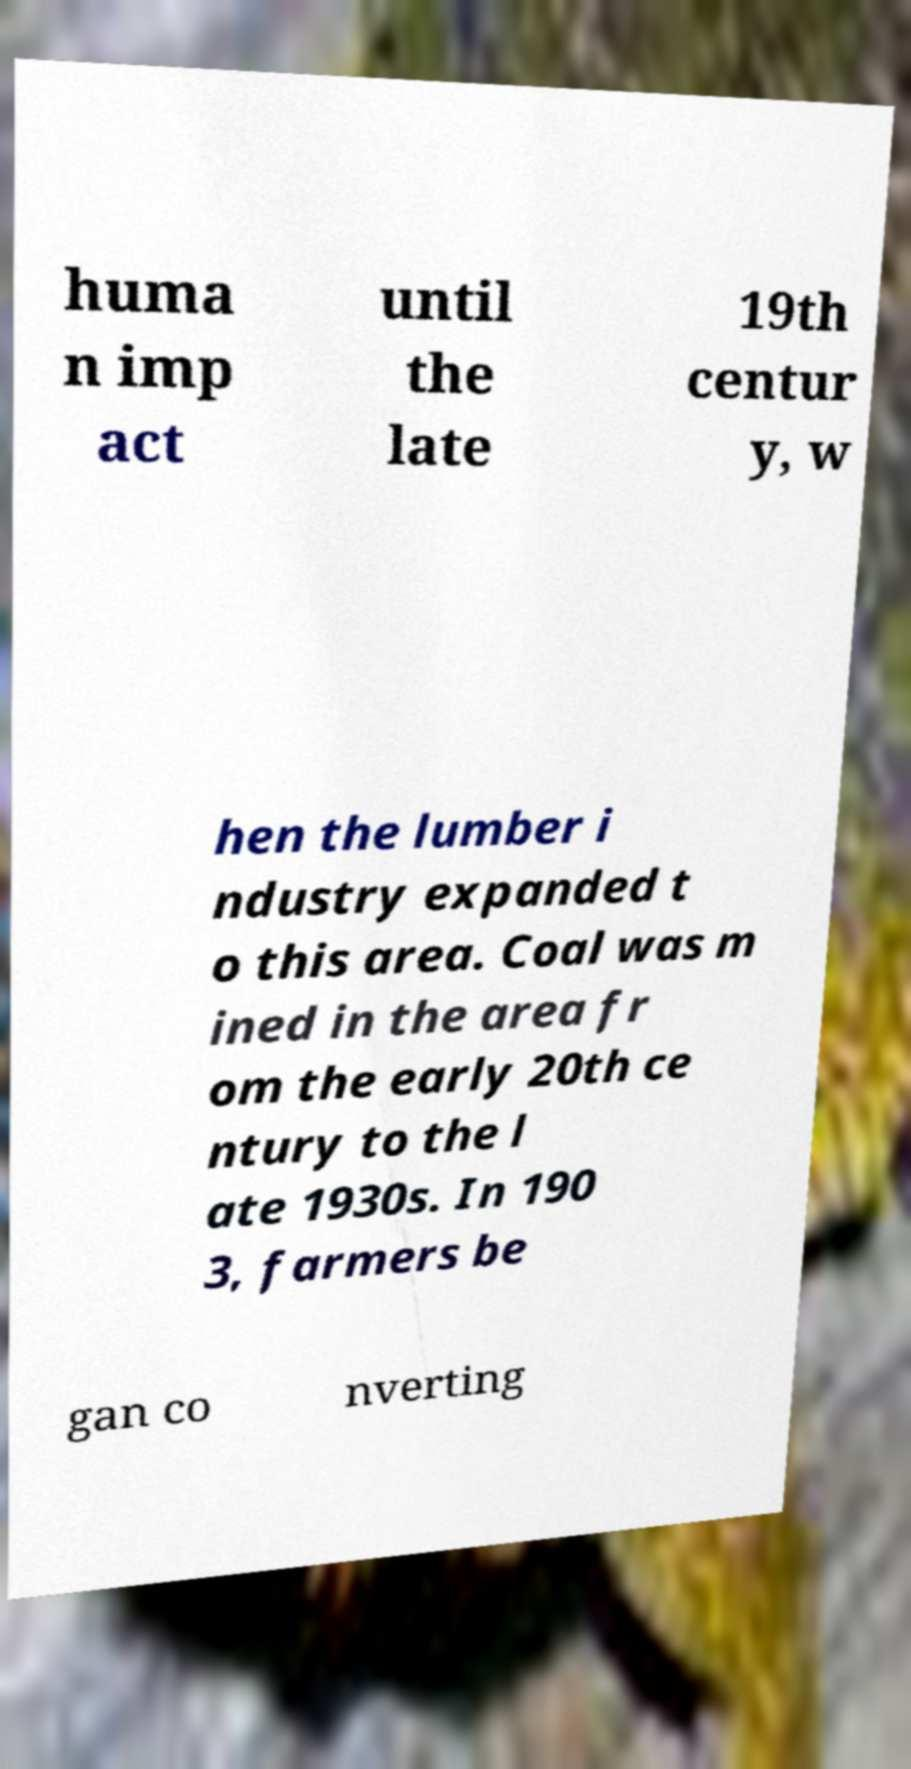There's text embedded in this image that I need extracted. Can you transcribe it verbatim? huma n imp act until the late 19th centur y, w hen the lumber i ndustry expanded t o this area. Coal was m ined in the area fr om the early 20th ce ntury to the l ate 1930s. In 190 3, farmers be gan co nverting 